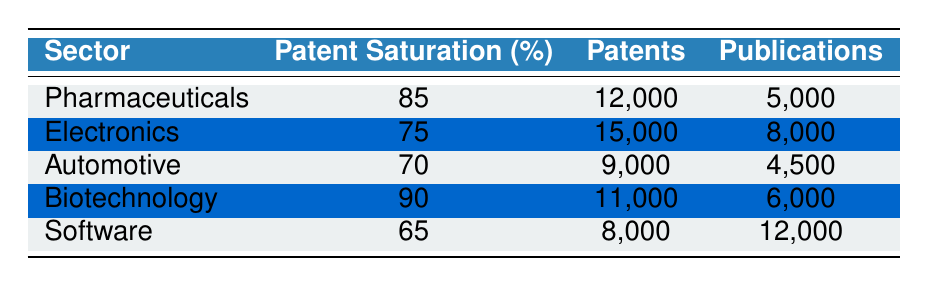What is the patent saturation percentage for the Software sector? The table shows that the patent saturation percentage for the Software sector is 65%.
Answer: 65 Which sector has the highest number of patents? By examining the values in the patents column, Electronics has the highest number of patents at 15,000.
Answer: Electronics How many more patents are there in Pharmaceuticals than in Automotive? The number of patents in Pharmaceuticals is 12,000 and in Automotive is 9,000. The difference is 12,000 - 9,000 = 3,000.
Answer: 3,000 Is the number of publications in Software greater than that in Pharmaceuticals? The table lists 12,000 publications for Software and 5,000 for Pharmaceuticals. Since 12,000 is greater than 5,000, the statement is true.
Answer: Yes What is the average number of publications across all sectors? Adding the publications: 5,000 (Pharmaceuticals) + 8,000 (Electronics) + 4,500 (Automotive) + 6,000 (Biotechnology) + 12,000 (Software) = 35,500. There are 5 sectors, so the average is 35,500 / 5 = 7,100.
Answer: 7,100 Which sector has the lowest patent saturation, and what is its value? The lowest patent saturation is found in the Software sector, with a value of 65%.
Answer: Software, 65 Do any sectors have equal numbers of patents and publications? Looking at the table, no sector has equal values in both patents and publications; each sector has different counts.
Answer: No Which sector has the highest publication count and what is the number? The Software sector has the highest publication count at 12,000.
Answer: Software, 12,000 If we sum the patents of Pharmaceuticals and Biotechnology, what do we get? The sum of patents in Pharmaceuticals (12,000) and Biotechnology (11,000) is 12,000 + 11,000 = 23,000.
Answer: 23,000 